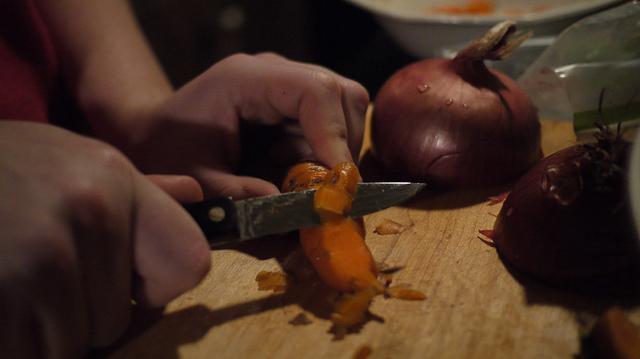How many knives are in the picture?
Give a very brief answer. 1. 